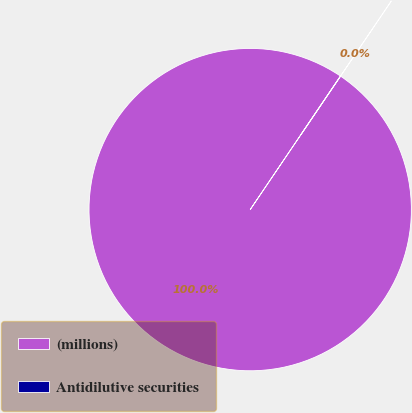Convert chart to OTSL. <chart><loc_0><loc_0><loc_500><loc_500><pie_chart><fcel>(millions)<fcel>Antidilutive securities<nl><fcel>99.99%<fcel>0.01%<nl></chart> 